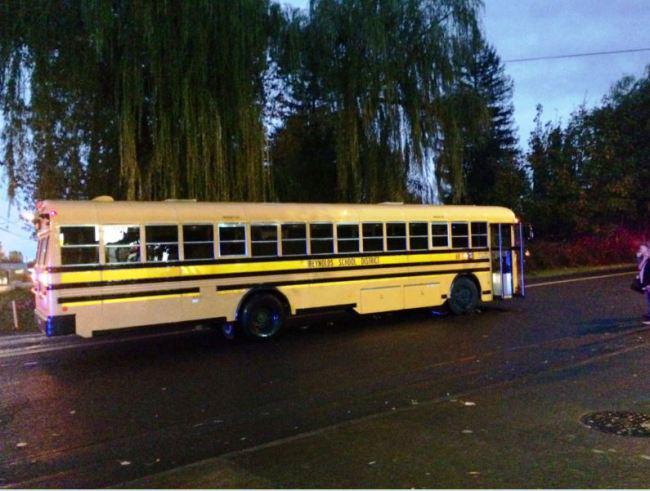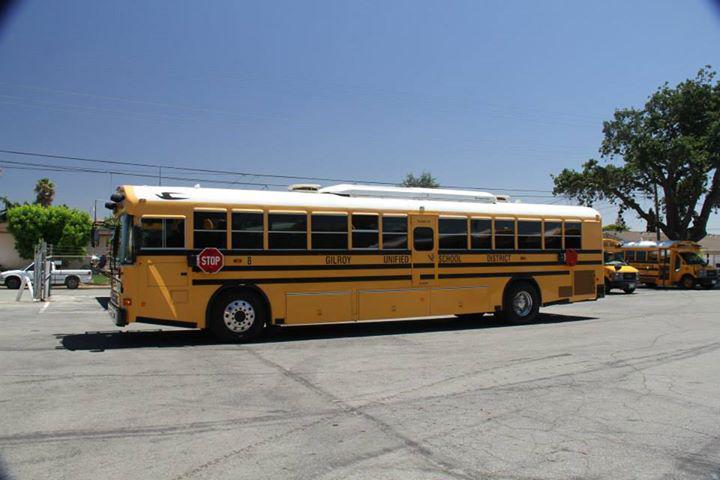The first image is the image on the left, the second image is the image on the right. Evaluate the accuracy of this statement regarding the images: "The school bus is in the stopped position.". Is it true? Answer yes or no. Yes. The first image is the image on the left, the second image is the image on the right. Examine the images to the left and right. Is the description "The buses on the left and right both face forward and angle slightly rightward, and people stand in front of the open door of at least one bus." accurate? Answer yes or no. No. 